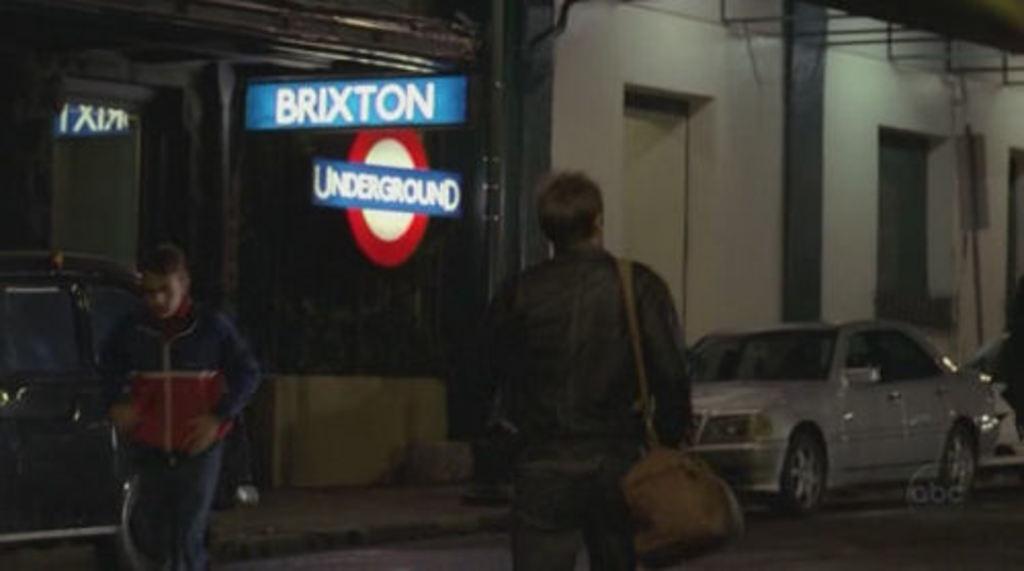Please provide a concise description of this image. In this picture there is a man who is wearing jacket and bag. He is standing on the road. On the left there is a man who is standing near to the black car. In the back I can see the sign boards, poles, building, doors and shelter. On the right I can see a white car which is parked near to the pole. 